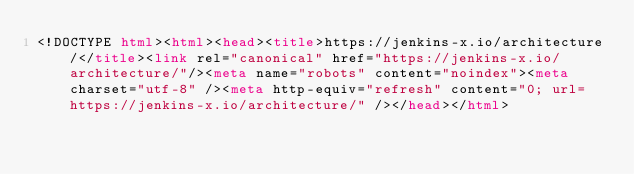<code> <loc_0><loc_0><loc_500><loc_500><_HTML_><!DOCTYPE html><html><head><title>https://jenkins-x.io/architecture/</title><link rel="canonical" href="https://jenkins-x.io/architecture/"/><meta name="robots" content="noindex"><meta charset="utf-8" /><meta http-equiv="refresh" content="0; url=https://jenkins-x.io/architecture/" /></head></html></code> 